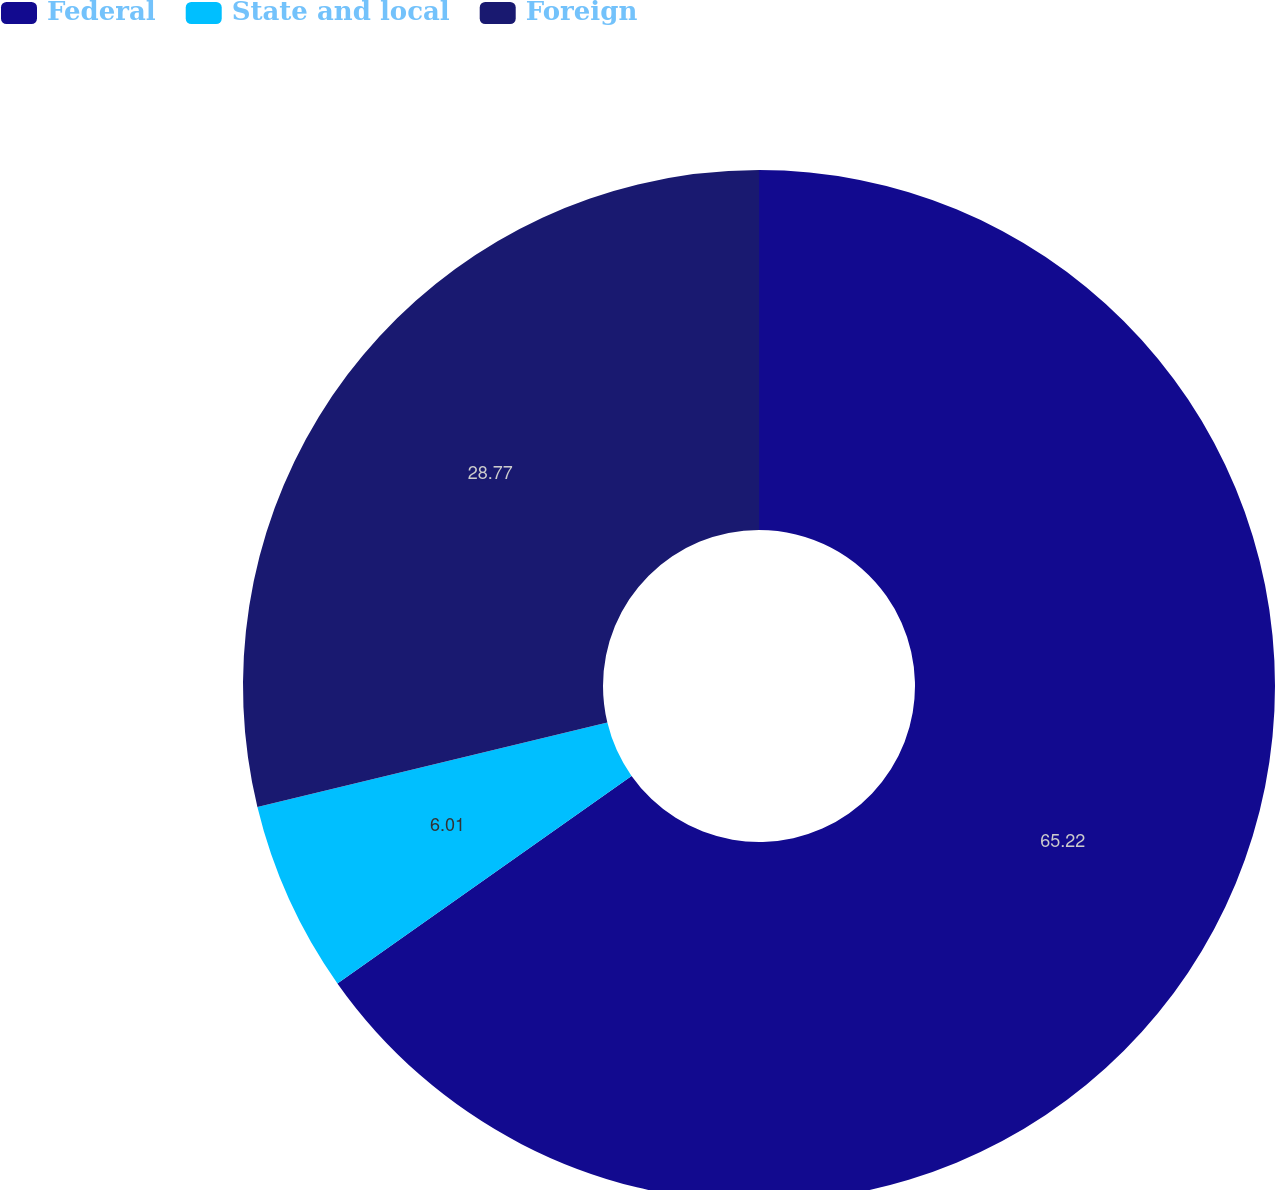Convert chart. <chart><loc_0><loc_0><loc_500><loc_500><pie_chart><fcel>Federal<fcel>State and local<fcel>Foreign<nl><fcel>65.22%<fcel>6.01%<fcel>28.77%<nl></chart> 